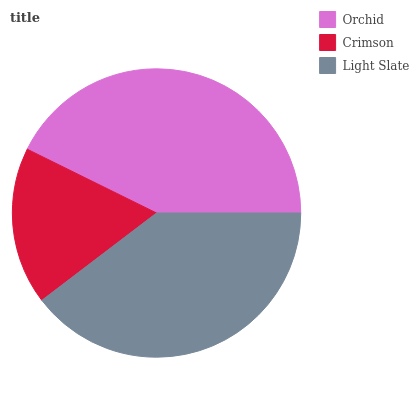Is Crimson the minimum?
Answer yes or no. Yes. Is Orchid the maximum?
Answer yes or no. Yes. Is Light Slate the minimum?
Answer yes or no. No. Is Light Slate the maximum?
Answer yes or no. No. Is Light Slate greater than Crimson?
Answer yes or no. Yes. Is Crimson less than Light Slate?
Answer yes or no. Yes. Is Crimson greater than Light Slate?
Answer yes or no. No. Is Light Slate less than Crimson?
Answer yes or no. No. Is Light Slate the high median?
Answer yes or no. Yes. Is Light Slate the low median?
Answer yes or no. Yes. Is Orchid the high median?
Answer yes or no. No. Is Orchid the low median?
Answer yes or no. No. 